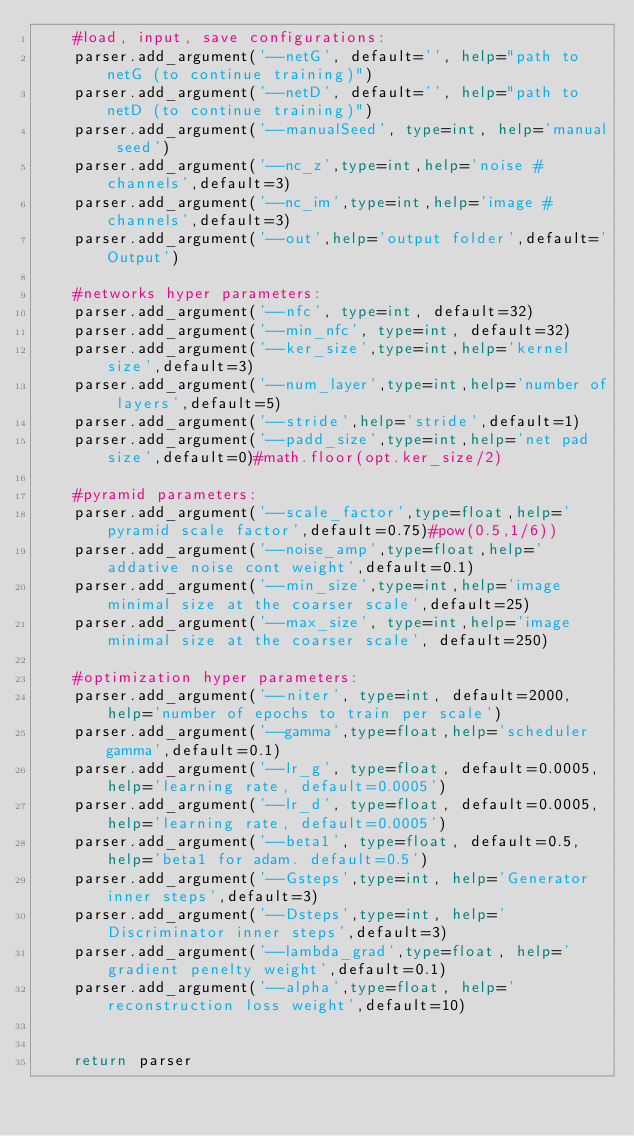Convert code to text. <code><loc_0><loc_0><loc_500><loc_500><_Python_>    #load, input, save configurations:
    parser.add_argument('--netG', default='', help="path to netG (to continue training)")
    parser.add_argument('--netD', default='', help="path to netD (to continue training)")
    parser.add_argument('--manualSeed', type=int, help='manual seed')
    parser.add_argument('--nc_z',type=int,help='noise # channels',default=3)
    parser.add_argument('--nc_im',type=int,help='image # channels',default=3)
    parser.add_argument('--out',help='output folder',default='Output')
        
    #networks hyper parameters:
    parser.add_argument('--nfc', type=int, default=32)
    parser.add_argument('--min_nfc', type=int, default=32)
    parser.add_argument('--ker_size',type=int,help='kernel size',default=3)
    parser.add_argument('--num_layer',type=int,help='number of layers',default=5)
    parser.add_argument('--stride',help='stride',default=1)
    parser.add_argument('--padd_size',type=int,help='net pad size',default=0)#math.floor(opt.ker_size/2)
        
    #pyramid parameters:
    parser.add_argument('--scale_factor',type=float,help='pyramid scale factor',default=0.75)#pow(0.5,1/6))
    parser.add_argument('--noise_amp',type=float,help='addative noise cont weight',default=0.1)
    parser.add_argument('--min_size',type=int,help='image minimal size at the coarser scale',default=25)
    parser.add_argument('--max_size', type=int,help='image minimal size at the coarser scale', default=250)

    #optimization hyper parameters:
    parser.add_argument('--niter', type=int, default=2000, help='number of epochs to train per scale')
    parser.add_argument('--gamma',type=float,help='scheduler gamma',default=0.1)
    parser.add_argument('--lr_g', type=float, default=0.0005, help='learning rate, default=0.0005')
    parser.add_argument('--lr_d', type=float, default=0.0005, help='learning rate, default=0.0005')
    parser.add_argument('--beta1', type=float, default=0.5, help='beta1 for adam. default=0.5')
    parser.add_argument('--Gsteps',type=int, help='Generator inner steps',default=3)
    parser.add_argument('--Dsteps',type=int, help='Discriminator inner steps',default=3)
    parser.add_argument('--lambda_grad',type=float, help='gradient penelty weight',default=0.1)
    parser.add_argument('--alpha',type=float, help='reconstruction loss weight',default=10)

    
    return parser
</code> 